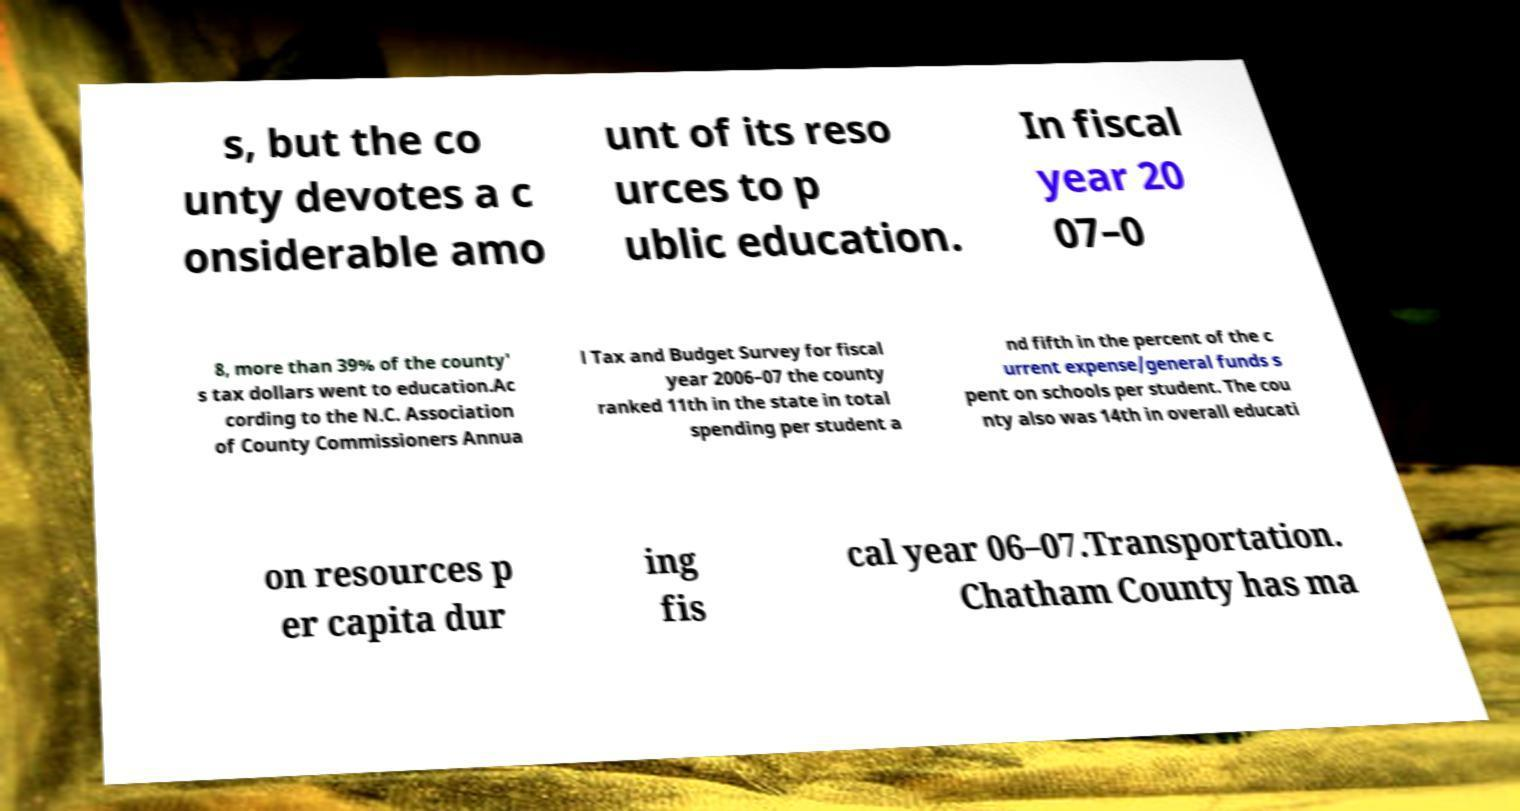Could you assist in decoding the text presented in this image and type it out clearly? s, but the co unty devotes a c onsiderable amo unt of its reso urces to p ublic education. In fiscal year 20 07–0 8, more than 39% of the county' s tax dollars went to education.Ac cording to the N.C. Association of County Commissioners Annua l Tax and Budget Survey for fiscal year 2006–07 the county ranked 11th in the state in total spending per student a nd fifth in the percent of the c urrent expense/general funds s pent on schools per student. The cou nty also was 14th in overall educati on resources p er capita dur ing fis cal year 06–07.Transportation. Chatham County has ma 